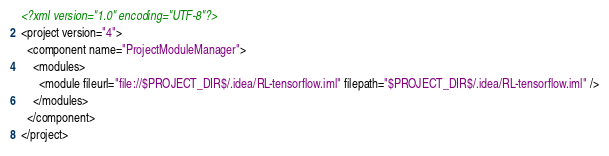Convert code to text. <code><loc_0><loc_0><loc_500><loc_500><_XML_><?xml version="1.0" encoding="UTF-8"?>
<project version="4">
  <component name="ProjectModuleManager">
    <modules>
      <module fileurl="file://$PROJECT_DIR$/.idea/RL-tensorflow.iml" filepath="$PROJECT_DIR$/.idea/RL-tensorflow.iml" />
    </modules>
  </component>
</project></code> 